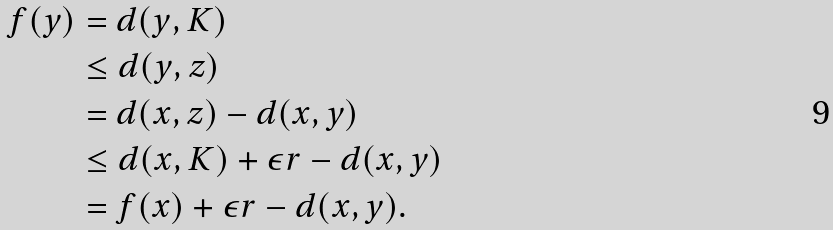<formula> <loc_0><loc_0><loc_500><loc_500>f ( y ) & = d ( y , K ) \\ & \leq d ( y , z ) \\ & = d ( x , z ) - d ( x , y ) \\ & \leq d ( x , K ) + \epsilon r - d ( x , y ) \\ & = f ( x ) + \epsilon r - d ( x , y ) .</formula> 